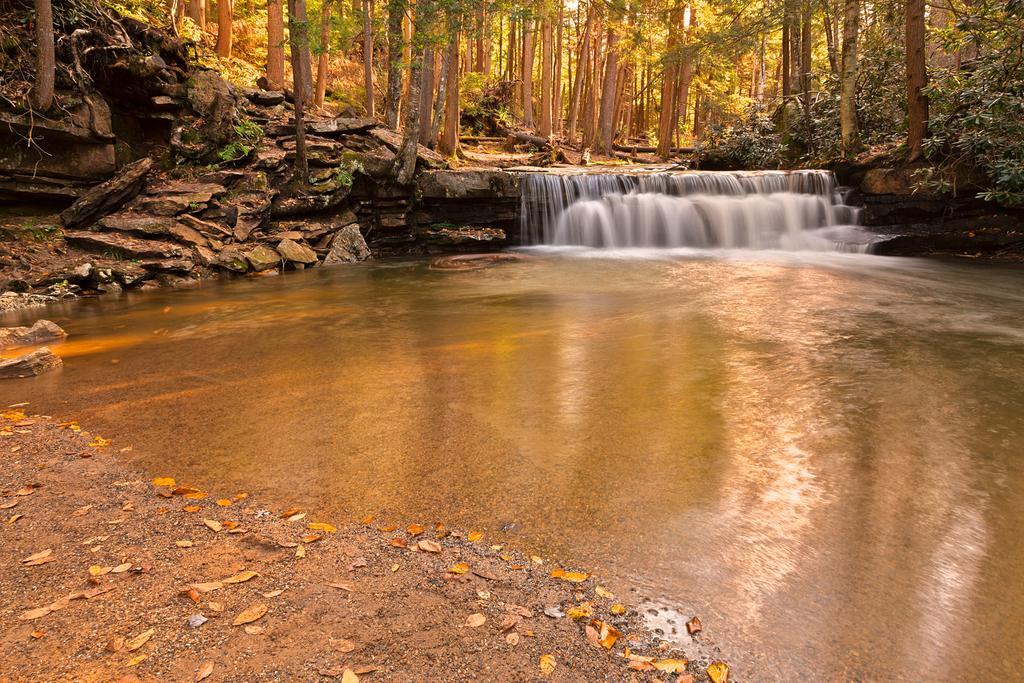How would you summarize this image in a sentence or two? This image is taken outdoors. At the bottom of the image there is a ground and there is a pond with water. In the background there are many trees and plants and there are a few rocks. 